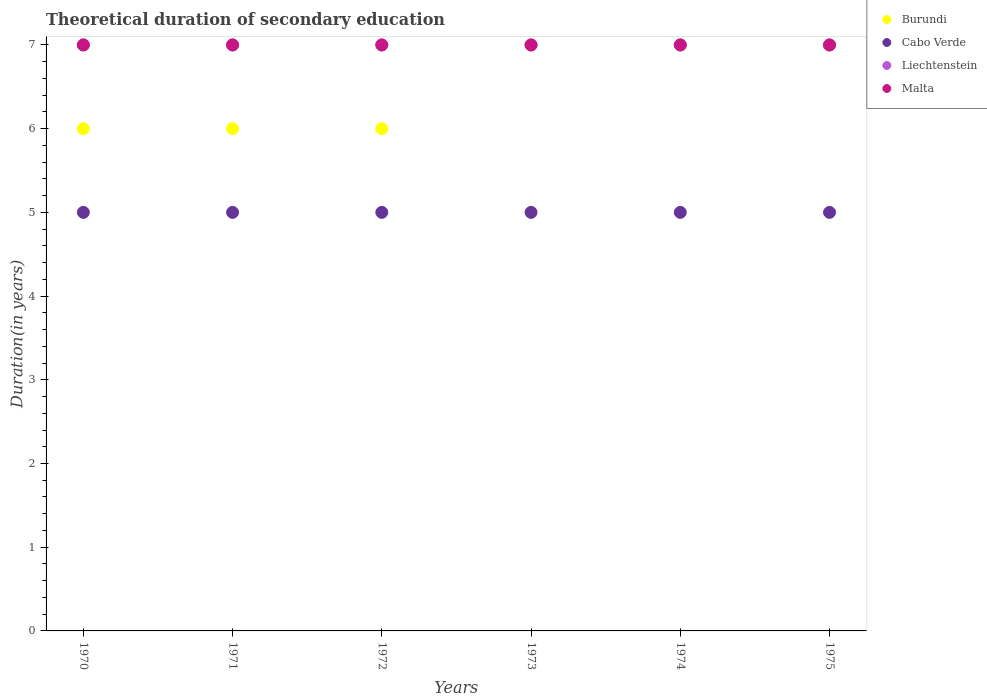Is the number of dotlines equal to the number of legend labels?
Provide a succinct answer. Yes. What is the total theoretical duration of secondary education in Burundi in 1972?
Make the answer very short. 6. Across all years, what is the maximum total theoretical duration of secondary education in Malta?
Give a very brief answer. 7. Across all years, what is the minimum total theoretical duration of secondary education in Liechtenstein?
Provide a succinct answer. 7. In which year was the total theoretical duration of secondary education in Liechtenstein maximum?
Give a very brief answer. 1970. What is the total total theoretical duration of secondary education in Cabo Verde in the graph?
Your answer should be very brief. 30. What is the difference between the total theoretical duration of secondary education in Cabo Verde in 1971 and that in 1972?
Keep it short and to the point. 0. What is the average total theoretical duration of secondary education in Burundi per year?
Provide a short and direct response. 6.5. In the year 1975, what is the difference between the total theoretical duration of secondary education in Liechtenstein and total theoretical duration of secondary education in Burundi?
Provide a short and direct response. 0. In how many years, is the total theoretical duration of secondary education in Burundi greater than 5.4 years?
Offer a terse response. 6. What is the ratio of the total theoretical duration of secondary education in Cabo Verde in 1970 to that in 1975?
Give a very brief answer. 1. What is the difference between the highest and the second highest total theoretical duration of secondary education in Burundi?
Your response must be concise. 0. What is the difference between the highest and the lowest total theoretical duration of secondary education in Burundi?
Make the answer very short. 1. In how many years, is the total theoretical duration of secondary education in Cabo Verde greater than the average total theoretical duration of secondary education in Cabo Verde taken over all years?
Make the answer very short. 0. Is the sum of the total theoretical duration of secondary education in Liechtenstein in 1970 and 1975 greater than the maximum total theoretical duration of secondary education in Malta across all years?
Your response must be concise. Yes. Is it the case that in every year, the sum of the total theoretical duration of secondary education in Malta and total theoretical duration of secondary education in Burundi  is greater than the sum of total theoretical duration of secondary education in Liechtenstein and total theoretical duration of secondary education in Cabo Verde?
Your answer should be compact. No. How many dotlines are there?
Your answer should be very brief. 4. What is the title of the graph?
Your response must be concise. Theoretical duration of secondary education. Does "Venezuela" appear as one of the legend labels in the graph?
Your response must be concise. No. What is the label or title of the Y-axis?
Your response must be concise. Duration(in years). What is the Duration(in years) in Cabo Verde in 1970?
Provide a succinct answer. 5. What is the Duration(in years) in Cabo Verde in 1971?
Offer a terse response. 5. What is the Duration(in years) of Malta in 1971?
Offer a very short reply. 7. What is the Duration(in years) in Burundi in 1972?
Provide a succinct answer. 6. What is the Duration(in years) in Cabo Verde in 1972?
Provide a succinct answer. 5. What is the Duration(in years) of Liechtenstein in 1972?
Keep it short and to the point. 7. What is the Duration(in years) in Malta in 1972?
Your answer should be compact. 7. What is the Duration(in years) in Burundi in 1973?
Provide a succinct answer. 7. What is the Duration(in years) of Cabo Verde in 1973?
Ensure brevity in your answer.  5. What is the Duration(in years) of Burundi in 1974?
Make the answer very short. 7. What is the Duration(in years) in Liechtenstein in 1975?
Your response must be concise. 7. Across all years, what is the maximum Duration(in years) in Cabo Verde?
Keep it short and to the point. 5. Across all years, what is the minimum Duration(in years) in Burundi?
Ensure brevity in your answer.  6. Across all years, what is the minimum Duration(in years) of Malta?
Make the answer very short. 7. What is the total Duration(in years) in Burundi in the graph?
Offer a very short reply. 39. What is the total Duration(in years) in Cabo Verde in the graph?
Provide a short and direct response. 30. What is the total Duration(in years) of Malta in the graph?
Provide a succinct answer. 42. What is the difference between the Duration(in years) in Liechtenstein in 1970 and that in 1971?
Provide a succinct answer. 0. What is the difference between the Duration(in years) in Malta in 1970 and that in 1971?
Provide a short and direct response. 0. What is the difference between the Duration(in years) of Liechtenstein in 1970 and that in 1972?
Make the answer very short. 0. What is the difference between the Duration(in years) in Burundi in 1970 and that in 1973?
Offer a very short reply. -1. What is the difference between the Duration(in years) in Liechtenstein in 1970 and that in 1973?
Offer a very short reply. 0. What is the difference between the Duration(in years) in Malta in 1970 and that in 1973?
Ensure brevity in your answer.  0. What is the difference between the Duration(in years) of Burundi in 1970 and that in 1974?
Your response must be concise. -1. What is the difference between the Duration(in years) in Burundi in 1970 and that in 1975?
Provide a succinct answer. -1. What is the difference between the Duration(in years) of Cabo Verde in 1970 and that in 1975?
Your answer should be very brief. 0. What is the difference between the Duration(in years) of Burundi in 1971 and that in 1972?
Your response must be concise. 0. What is the difference between the Duration(in years) in Cabo Verde in 1971 and that in 1972?
Keep it short and to the point. 0. What is the difference between the Duration(in years) of Liechtenstein in 1971 and that in 1972?
Give a very brief answer. 0. What is the difference between the Duration(in years) of Cabo Verde in 1971 and that in 1973?
Your answer should be compact. 0. What is the difference between the Duration(in years) of Malta in 1971 and that in 1973?
Offer a terse response. 0. What is the difference between the Duration(in years) in Burundi in 1971 and that in 1974?
Provide a short and direct response. -1. What is the difference between the Duration(in years) of Cabo Verde in 1971 and that in 1974?
Provide a short and direct response. 0. What is the difference between the Duration(in years) in Malta in 1971 and that in 1974?
Your answer should be very brief. 0. What is the difference between the Duration(in years) of Cabo Verde in 1971 and that in 1975?
Provide a succinct answer. 0. What is the difference between the Duration(in years) in Cabo Verde in 1972 and that in 1973?
Your answer should be very brief. 0. What is the difference between the Duration(in years) in Malta in 1972 and that in 1973?
Your response must be concise. 0. What is the difference between the Duration(in years) of Cabo Verde in 1972 and that in 1974?
Ensure brevity in your answer.  0. What is the difference between the Duration(in years) of Malta in 1972 and that in 1974?
Keep it short and to the point. 0. What is the difference between the Duration(in years) of Burundi in 1972 and that in 1975?
Ensure brevity in your answer.  -1. What is the difference between the Duration(in years) in Cabo Verde in 1972 and that in 1975?
Give a very brief answer. 0. What is the difference between the Duration(in years) of Liechtenstein in 1972 and that in 1975?
Your answer should be compact. 0. What is the difference between the Duration(in years) of Burundi in 1973 and that in 1974?
Offer a terse response. 0. What is the difference between the Duration(in years) of Cabo Verde in 1973 and that in 1975?
Provide a short and direct response. 0. What is the difference between the Duration(in years) of Liechtenstein in 1973 and that in 1975?
Your response must be concise. 0. What is the difference between the Duration(in years) in Malta in 1973 and that in 1975?
Make the answer very short. 0. What is the difference between the Duration(in years) in Burundi in 1974 and that in 1975?
Your response must be concise. 0. What is the difference between the Duration(in years) in Cabo Verde in 1974 and that in 1975?
Provide a succinct answer. 0. What is the difference between the Duration(in years) in Burundi in 1970 and the Duration(in years) in Cabo Verde in 1971?
Your response must be concise. 1. What is the difference between the Duration(in years) of Burundi in 1970 and the Duration(in years) of Malta in 1971?
Ensure brevity in your answer.  -1. What is the difference between the Duration(in years) of Cabo Verde in 1970 and the Duration(in years) of Liechtenstein in 1971?
Your answer should be compact. -2. What is the difference between the Duration(in years) of Cabo Verde in 1970 and the Duration(in years) of Malta in 1971?
Provide a short and direct response. -2. What is the difference between the Duration(in years) in Burundi in 1970 and the Duration(in years) in Liechtenstein in 1972?
Keep it short and to the point. -1. What is the difference between the Duration(in years) in Cabo Verde in 1970 and the Duration(in years) in Liechtenstein in 1972?
Your answer should be compact. -2. What is the difference between the Duration(in years) of Burundi in 1970 and the Duration(in years) of Liechtenstein in 1973?
Provide a short and direct response. -1. What is the difference between the Duration(in years) of Burundi in 1970 and the Duration(in years) of Malta in 1973?
Offer a very short reply. -1. What is the difference between the Duration(in years) in Cabo Verde in 1970 and the Duration(in years) in Liechtenstein in 1973?
Your answer should be very brief. -2. What is the difference between the Duration(in years) of Cabo Verde in 1970 and the Duration(in years) of Malta in 1973?
Provide a succinct answer. -2. What is the difference between the Duration(in years) of Burundi in 1970 and the Duration(in years) of Malta in 1974?
Offer a very short reply. -1. What is the difference between the Duration(in years) of Cabo Verde in 1970 and the Duration(in years) of Liechtenstein in 1974?
Offer a terse response. -2. What is the difference between the Duration(in years) of Burundi in 1970 and the Duration(in years) of Liechtenstein in 1975?
Keep it short and to the point. -1. What is the difference between the Duration(in years) of Cabo Verde in 1970 and the Duration(in years) of Liechtenstein in 1975?
Give a very brief answer. -2. What is the difference between the Duration(in years) in Cabo Verde in 1970 and the Duration(in years) in Malta in 1975?
Make the answer very short. -2. What is the difference between the Duration(in years) of Burundi in 1971 and the Duration(in years) of Cabo Verde in 1972?
Your response must be concise. 1. What is the difference between the Duration(in years) in Burundi in 1971 and the Duration(in years) in Malta in 1972?
Offer a terse response. -1. What is the difference between the Duration(in years) of Cabo Verde in 1971 and the Duration(in years) of Liechtenstein in 1972?
Your answer should be very brief. -2. What is the difference between the Duration(in years) of Cabo Verde in 1971 and the Duration(in years) of Malta in 1972?
Your response must be concise. -2. What is the difference between the Duration(in years) in Burundi in 1971 and the Duration(in years) in Cabo Verde in 1973?
Make the answer very short. 1. What is the difference between the Duration(in years) in Cabo Verde in 1971 and the Duration(in years) in Liechtenstein in 1973?
Keep it short and to the point. -2. What is the difference between the Duration(in years) in Cabo Verde in 1971 and the Duration(in years) in Malta in 1973?
Your response must be concise. -2. What is the difference between the Duration(in years) of Burundi in 1971 and the Duration(in years) of Malta in 1974?
Provide a succinct answer. -1. What is the difference between the Duration(in years) in Cabo Verde in 1971 and the Duration(in years) in Liechtenstein in 1974?
Your answer should be compact. -2. What is the difference between the Duration(in years) of Liechtenstein in 1971 and the Duration(in years) of Malta in 1974?
Keep it short and to the point. 0. What is the difference between the Duration(in years) of Burundi in 1971 and the Duration(in years) of Cabo Verde in 1975?
Your answer should be compact. 1. What is the difference between the Duration(in years) of Cabo Verde in 1971 and the Duration(in years) of Malta in 1975?
Your answer should be compact. -2. What is the difference between the Duration(in years) in Liechtenstein in 1971 and the Duration(in years) in Malta in 1975?
Offer a terse response. 0. What is the difference between the Duration(in years) in Burundi in 1972 and the Duration(in years) in Liechtenstein in 1973?
Your response must be concise. -1. What is the difference between the Duration(in years) in Cabo Verde in 1972 and the Duration(in years) in Malta in 1973?
Your response must be concise. -2. What is the difference between the Duration(in years) of Liechtenstein in 1972 and the Duration(in years) of Malta in 1973?
Your answer should be very brief. 0. What is the difference between the Duration(in years) in Burundi in 1972 and the Duration(in years) in Cabo Verde in 1974?
Provide a short and direct response. 1. What is the difference between the Duration(in years) of Burundi in 1972 and the Duration(in years) of Liechtenstein in 1974?
Your answer should be very brief. -1. What is the difference between the Duration(in years) in Cabo Verde in 1972 and the Duration(in years) in Malta in 1974?
Provide a short and direct response. -2. What is the difference between the Duration(in years) of Liechtenstein in 1972 and the Duration(in years) of Malta in 1974?
Make the answer very short. 0. What is the difference between the Duration(in years) in Burundi in 1972 and the Duration(in years) in Malta in 1975?
Offer a very short reply. -1. What is the difference between the Duration(in years) of Cabo Verde in 1972 and the Duration(in years) of Liechtenstein in 1975?
Provide a short and direct response. -2. What is the difference between the Duration(in years) in Liechtenstein in 1972 and the Duration(in years) in Malta in 1975?
Ensure brevity in your answer.  0. What is the difference between the Duration(in years) in Burundi in 1973 and the Duration(in years) in Cabo Verde in 1974?
Make the answer very short. 2. What is the difference between the Duration(in years) of Burundi in 1973 and the Duration(in years) of Malta in 1974?
Keep it short and to the point. 0. What is the difference between the Duration(in years) of Cabo Verde in 1973 and the Duration(in years) of Liechtenstein in 1974?
Keep it short and to the point. -2. What is the difference between the Duration(in years) of Cabo Verde in 1973 and the Duration(in years) of Malta in 1974?
Provide a succinct answer. -2. What is the difference between the Duration(in years) in Burundi in 1973 and the Duration(in years) in Liechtenstein in 1975?
Keep it short and to the point. 0. What is the difference between the Duration(in years) in Cabo Verde in 1973 and the Duration(in years) in Liechtenstein in 1975?
Your response must be concise. -2. What is the difference between the Duration(in years) in Liechtenstein in 1973 and the Duration(in years) in Malta in 1975?
Offer a very short reply. 0. What is the difference between the Duration(in years) in Burundi in 1974 and the Duration(in years) in Liechtenstein in 1975?
Your answer should be very brief. 0. What is the difference between the Duration(in years) in Cabo Verde in 1974 and the Duration(in years) in Malta in 1975?
Ensure brevity in your answer.  -2. What is the difference between the Duration(in years) of Liechtenstein in 1974 and the Duration(in years) of Malta in 1975?
Your response must be concise. 0. What is the average Duration(in years) of Burundi per year?
Provide a short and direct response. 6.5. What is the average Duration(in years) of Cabo Verde per year?
Offer a terse response. 5. What is the average Duration(in years) in Liechtenstein per year?
Offer a very short reply. 7. In the year 1970, what is the difference between the Duration(in years) in Burundi and Duration(in years) in Cabo Verde?
Your answer should be very brief. 1. In the year 1970, what is the difference between the Duration(in years) in Cabo Verde and Duration(in years) in Liechtenstein?
Provide a short and direct response. -2. In the year 1970, what is the difference between the Duration(in years) of Cabo Verde and Duration(in years) of Malta?
Ensure brevity in your answer.  -2. In the year 1971, what is the difference between the Duration(in years) in Burundi and Duration(in years) in Cabo Verde?
Provide a short and direct response. 1. In the year 1971, what is the difference between the Duration(in years) in Burundi and Duration(in years) in Liechtenstein?
Keep it short and to the point. -1. In the year 1971, what is the difference between the Duration(in years) of Cabo Verde and Duration(in years) of Liechtenstein?
Provide a succinct answer. -2. In the year 1971, what is the difference between the Duration(in years) of Liechtenstein and Duration(in years) of Malta?
Keep it short and to the point. 0. In the year 1972, what is the difference between the Duration(in years) in Burundi and Duration(in years) in Cabo Verde?
Offer a very short reply. 1. In the year 1972, what is the difference between the Duration(in years) of Cabo Verde and Duration(in years) of Liechtenstein?
Give a very brief answer. -2. In the year 1973, what is the difference between the Duration(in years) of Burundi and Duration(in years) of Cabo Verde?
Your answer should be very brief. 2. In the year 1973, what is the difference between the Duration(in years) of Burundi and Duration(in years) of Liechtenstein?
Give a very brief answer. 0. In the year 1973, what is the difference between the Duration(in years) in Burundi and Duration(in years) in Malta?
Provide a short and direct response. 0. In the year 1973, what is the difference between the Duration(in years) of Cabo Verde and Duration(in years) of Liechtenstein?
Your answer should be compact. -2. In the year 1974, what is the difference between the Duration(in years) in Burundi and Duration(in years) in Cabo Verde?
Make the answer very short. 2. In the year 1974, what is the difference between the Duration(in years) of Burundi and Duration(in years) of Liechtenstein?
Make the answer very short. 0. In the year 1974, what is the difference between the Duration(in years) of Liechtenstein and Duration(in years) of Malta?
Keep it short and to the point. 0. In the year 1975, what is the difference between the Duration(in years) in Burundi and Duration(in years) in Malta?
Your answer should be compact. 0. In the year 1975, what is the difference between the Duration(in years) in Cabo Verde and Duration(in years) in Malta?
Make the answer very short. -2. In the year 1975, what is the difference between the Duration(in years) of Liechtenstein and Duration(in years) of Malta?
Your response must be concise. 0. What is the ratio of the Duration(in years) of Burundi in 1970 to that in 1971?
Provide a short and direct response. 1. What is the ratio of the Duration(in years) in Malta in 1970 to that in 1971?
Make the answer very short. 1. What is the ratio of the Duration(in years) in Burundi in 1970 to that in 1972?
Ensure brevity in your answer.  1. What is the ratio of the Duration(in years) of Cabo Verde in 1970 to that in 1972?
Your response must be concise. 1. What is the ratio of the Duration(in years) of Liechtenstein in 1970 to that in 1972?
Offer a terse response. 1. What is the ratio of the Duration(in years) of Malta in 1970 to that in 1972?
Offer a terse response. 1. What is the ratio of the Duration(in years) in Liechtenstein in 1970 to that in 1973?
Your response must be concise. 1. What is the ratio of the Duration(in years) in Malta in 1970 to that in 1973?
Provide a short and direct response. 1. What is the ratio of the Duration(in years) in Burundi in 1970 to that in 1974?
Give a very brief answer. 0.86. What is the ratio of the Duration(in years) in Cabo Verde in 1970 to that in 1974?
Keep it short and to the point. 1. What is the ratio of the Duration(in years) in Liechtenstein in 1970 to that in 1975?
Provide a short and direct response. 1. What is the ratio of the Duration(in years) in Malta in 1970 to that in 1975?
Your answer should be compact. 1. What is the ratio of the Duration(in years) of Cabo Verde in 1971 to that in 1972?
Give a very brief answer. 1. What is the ratio of the Duration(in years) of Malta in 1971 to that in 1972?
Offer a very short reply. 1. What is the ratio of the Duration(in years) in Burundi in 1971 to that in 1974?
Provide a short and direct response. 0.86. What is the ratio of the Duration(in years) of Cabo Verde in 1971 to that in 1974?
Offer a very short reply. 1. What is the ratio of the Duration(in years) in Cabo Verde in 1971 to that in 1975?
Your response must be concise. 1. What is the ratio of the Duration(in years) in Liechtenstein in 1971 to that in 1975?
Offer a very short reply. 1. What is the ratio of the Duration(in years) in Cabo Verde in 1972 to that in 1973?
Your answer should be very brief. 1. What is the ratio of the Duration(in years) of Burundi in 1972 to that in 1974?
Offer a very short reply. 0.86. What is the ratio of the Duration(in years) of Liechtenstein in 1972 to that in 1974?
Provide a short and direct response. 1. What is the ratio of the Duration(in years) of Malta in 1972 to that in 1974?
Provide a succinct answer. 1. What is the ratio of the Duration(in years) of Malta in 1972 to that in 1975?
Provide a succinct answer. 1. What is the ratio of the Duration(in years) of Burundi in 1973 to that in 1974?
Ensure brevity in your answer.  1. What is the ratio of the Duration(in years) in Liechtenstein in 1973 to that in 1974?
Your answer should be very brief. 1. What is the ratio of the Duration(in years) of Cabo Verde in 1973 to that in 1975?
Offer a very short reply. 1. What is the ratio of the Duration(in years) in Liechtenstein in 1973 to that in 1975?
Your answer should be very brief. 1. What is the ratio of the Duration(in years) of Burundi in 1974 to that in 1975?
Give a very brief answer. 1. What is the ratio of the Duration(in years) of Cabo Verde in 1974 to that in 1975?
Keep it short and to the point. 1. What is the ratio of the Duration(in years) of Malta in 1974 to that in 1975?
Provide a succinct answer. 1. What is the difference between the highest and the second highest Duration(in years) of Malta?
Your answer should be very brief. 0. What is the difference between the highest and the lowest Duration(in years) of Cabo Verde?
Provide a succinct answer. 0. 